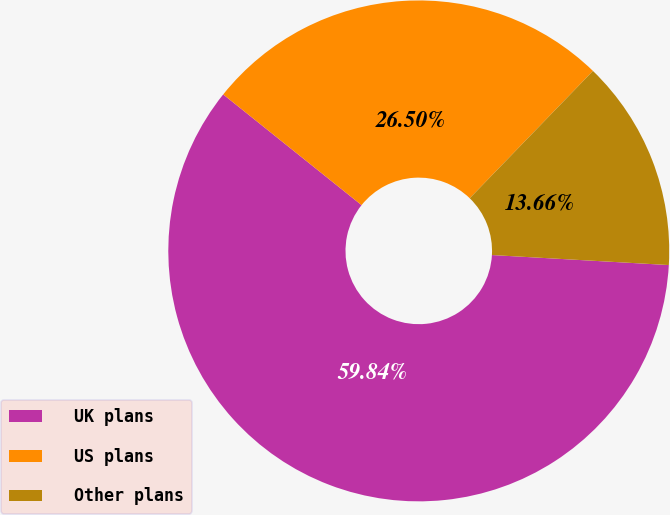<chart> <loc_0><loc_0><loc_500><loc_500><pie_chart><fcel>UK plans<fcel>US plans<fcel>Other plans<nl><fcel>59.84%<fcel>26.5%<fcel>13.66%<nl></chart> 